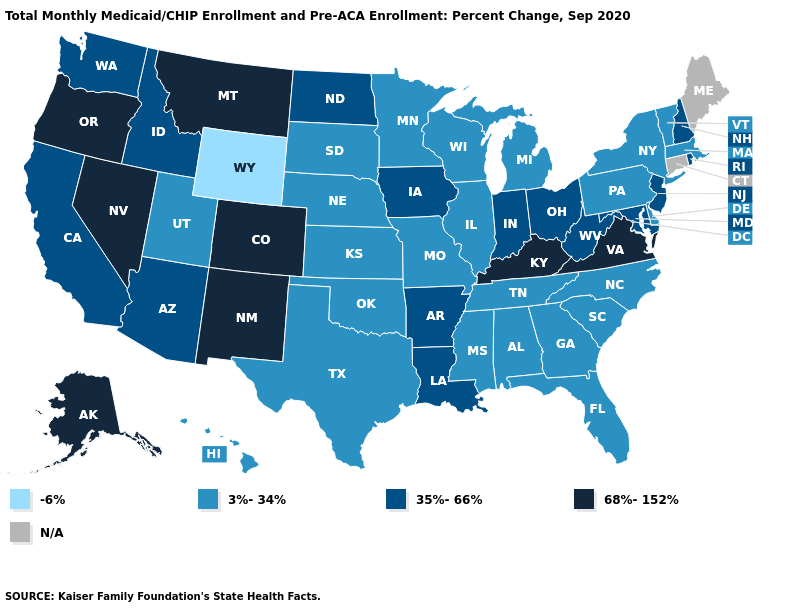Name the states that have a value in the range 68%-152%?
Give a very brief answer. Alaska, Colorado, Kentucky, Montana, Nevada, New Mexico, Oregon, Virginia. Name the states that have a value in the range 68%-152%?
Quick response, please. Alaska, Colorado, Kentucky, Montana, Nevada, New Mexico, Oregon, Virginia. What is the lowest value in the USA?
Short answer required. -6%. What is the lowest value in the USA?
Be succinct. -6%. Does New Hampshire have the lowest value in the USA?
Answer briefly. No. Which states hav the highest value in the West?
Be succinct. Alaska, Colorado, Montana, Nevada, New Mexico, Oregon. What is the value of Mississippi?
Short answer required. 3%-34%. What is the value of Alaska?
Concise answer only. 68%-152%. Does the first symbol in the legend represent the smallest category?
Quick response, please. Yes. Name the states that have a value in the range 3%-34%?
Quick response, please. Alabama, Delaware, Florida, Georgia, Hawaii, Illinois, Kansas, Massachusetts, Michigan, Minnesota, Mississippi, Missouri, Nebraska, New York, North Carolina, Oklahoma, Pennsylvania, South Carolina, South Dakota, Tennessee, Texas, Utah, Vermont, Wisconsin. Does Wyoming have the lowest value in the USA?
Answer briefly. Yes. Name the states that have a value in the range N/A?
Concise answer only. Connecticut, Maine. Which states hav the highest value in the MidWest?
Short answer required. Indiana, Iowa, North Dakota, Ohio. 